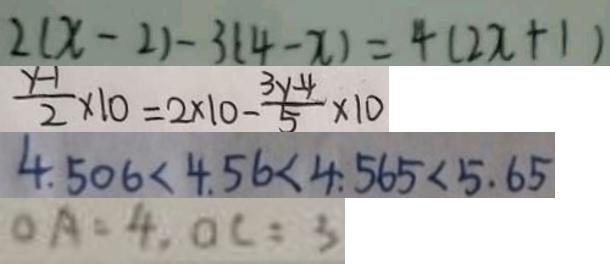Convert formula to latex. <formula><loc_0><loc_0><loc_500><loc_500>2 ( x - 2 ) - 3 ( 4 - x ) = 4 ( 2 x + 1 ) 
 \frac { y - 1 } { 2 } \times 1 0 = 2 \times 1 0 - \frac { 3 y - 4 } { 5 } \times 1 0 
 4 . 5 0 6 < 4 . 5 6 < 4 . 5 6 5 < 5 . 6 5 
 O A = 4 , O C = 3</formula> 